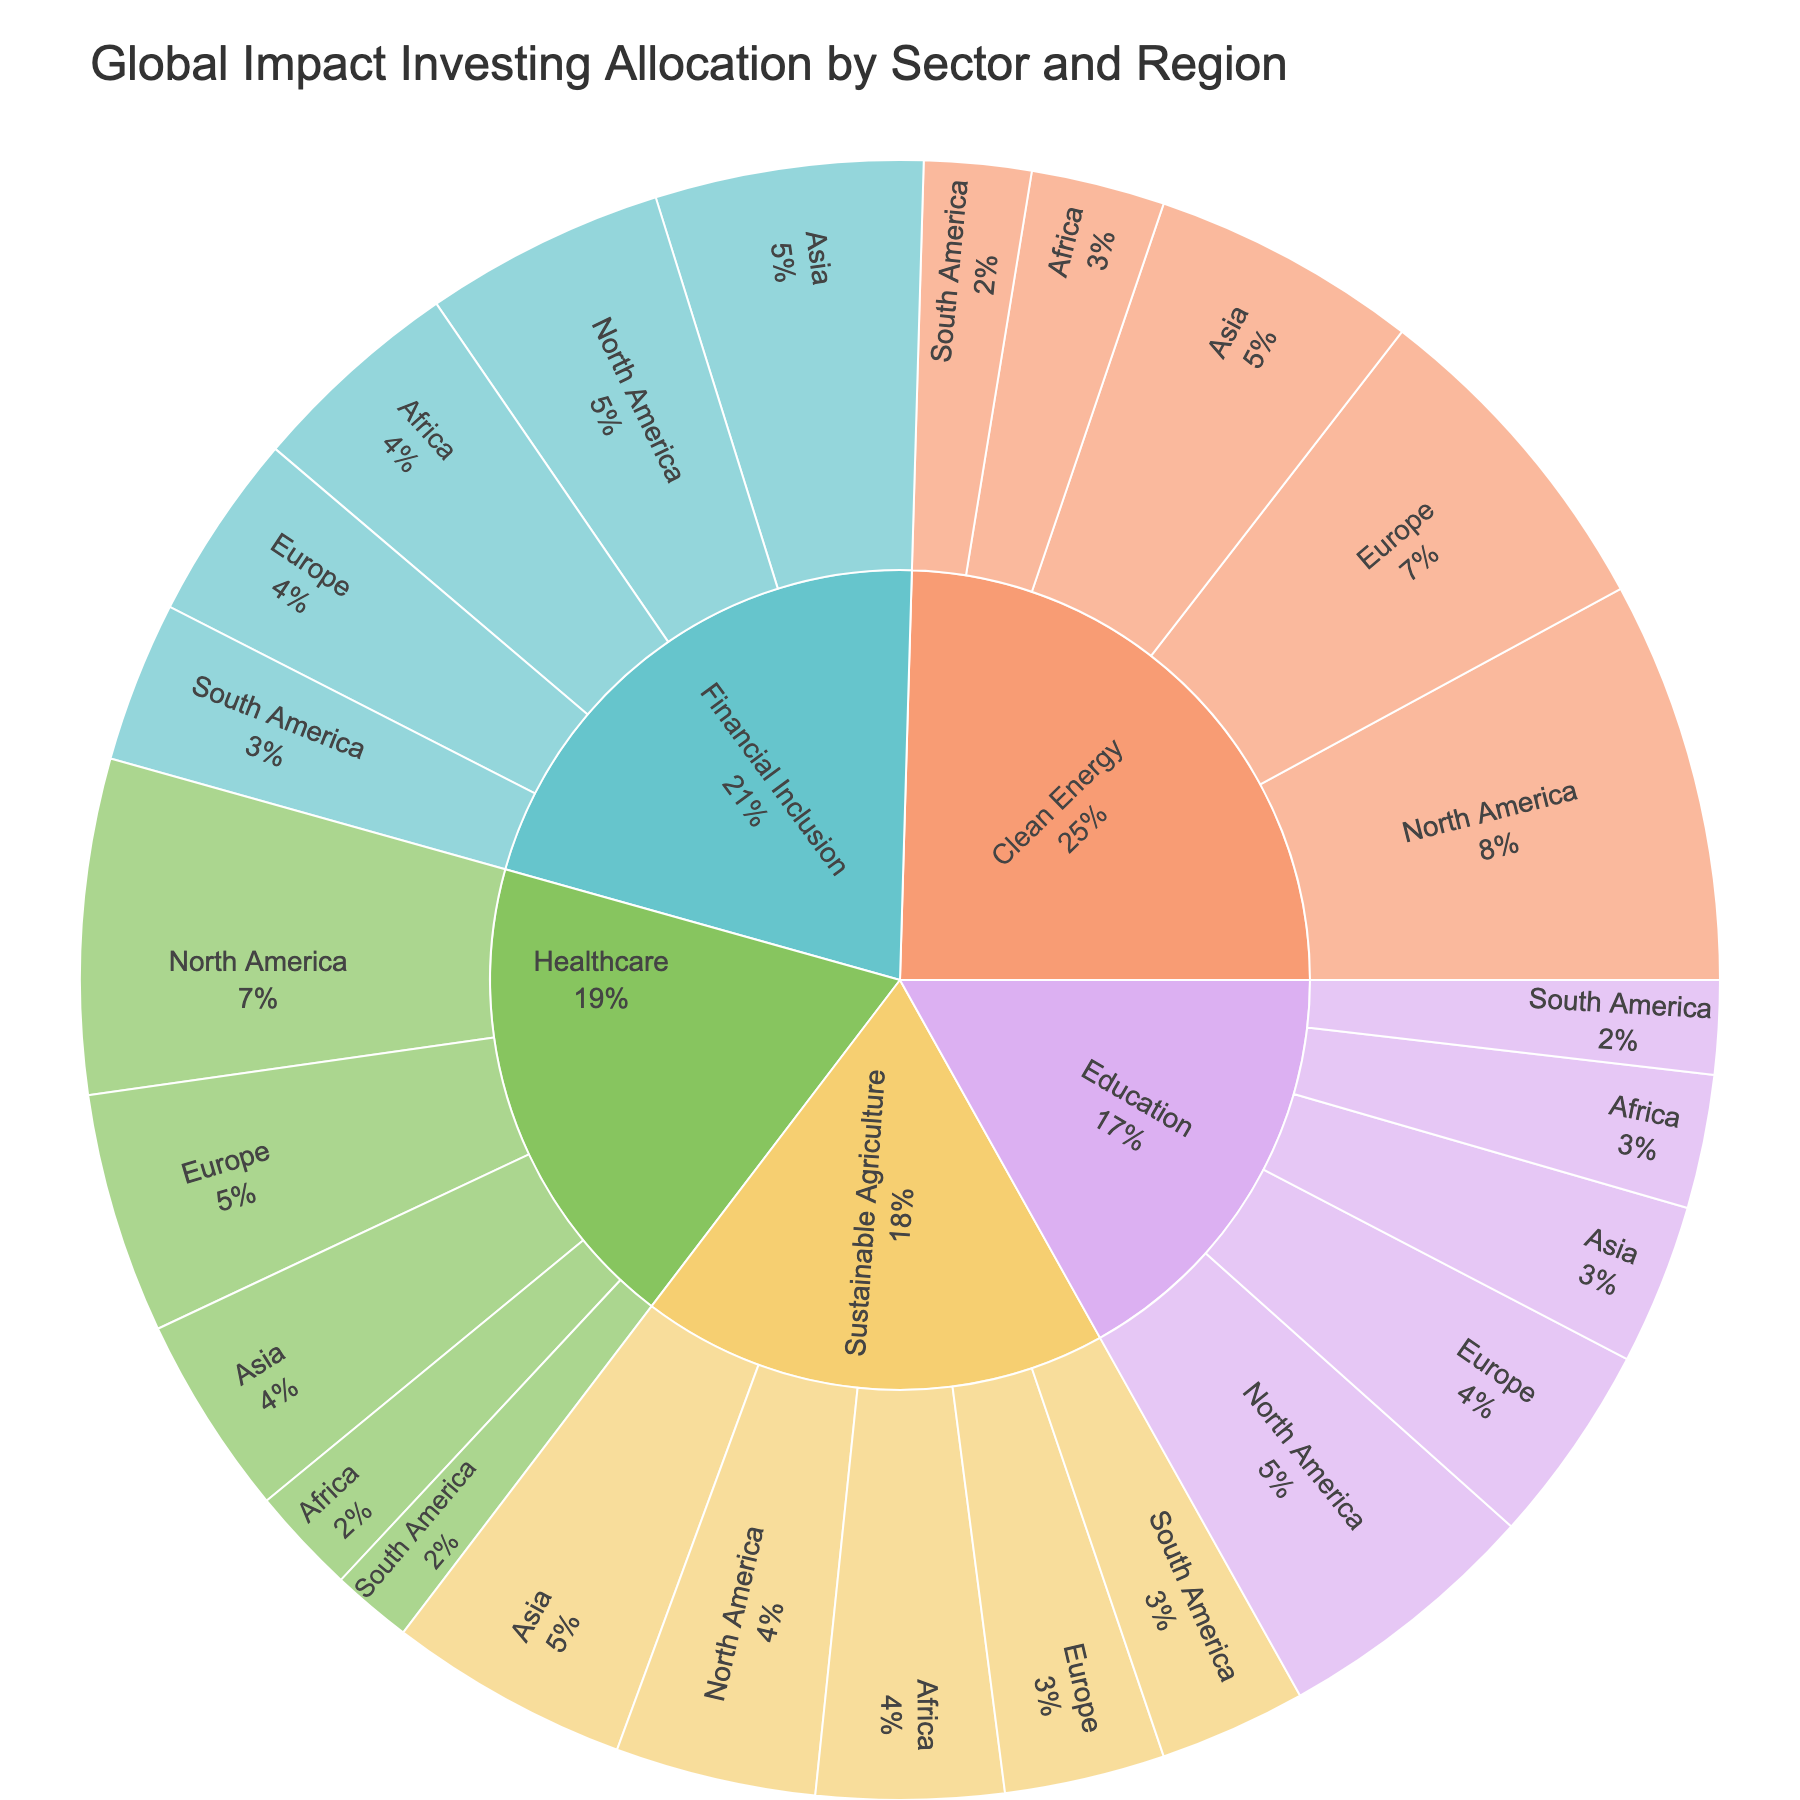what is the title of the figure? The title is prominently displayed at the top of the sunburst plot
Answer: Global Impact Investing Allocation by Sector and Region Which sector has the highest overall allocation? By observing the sunburst plot, the sector with the largest segment, which means the highest overall value, stands out
Answer: Clean Energy How many sectors are depicted in the figure? The sunburst plot shows different color-coded sectors at the first level branching out from the center
Answer: Five Which region within 'Healthcare' has the smallest allocation? Look at the 'Healthcare' section of the plot, then identify the smallest region segment
Answer: South America Compare the values for 'Clean Energy' in North America and Europe. Which is higher? Refer to the 'Clean Energy' section and compare the sizes of the segments for North America and Europe
Answer: North America What is the value of 'Sustainable Agriculture' in Africa? Locate the 'Sustainable Agriculture' sector and then pinpoint the segment for Africa to read the value
Answer: 140 Which sector has the least allocation in South America? Examine the segments branching from South America to identify the smallest one
Answer: Healthcare Calculate the total allocation for 'Financial Inclusion' across all regions. Sum the values for 'Financial Inclusion' in each region: 180 + 140 + 200 + 160 + 120 = 800
Answer: 800 What percentage of the total allocation does 'Education' in Asia represent? Sum all values for 'Education' and compare it to its specific allocation in Asia (120): (120/640)*100 is approximately 18.75%
Answer: 18.75% Compare North America's allocation in 'Healthcare' and 'Education'. Which is lower? Look at the segments for 'Healthcare' and 'Education' in North America and compare their sizes
Answer: Education 